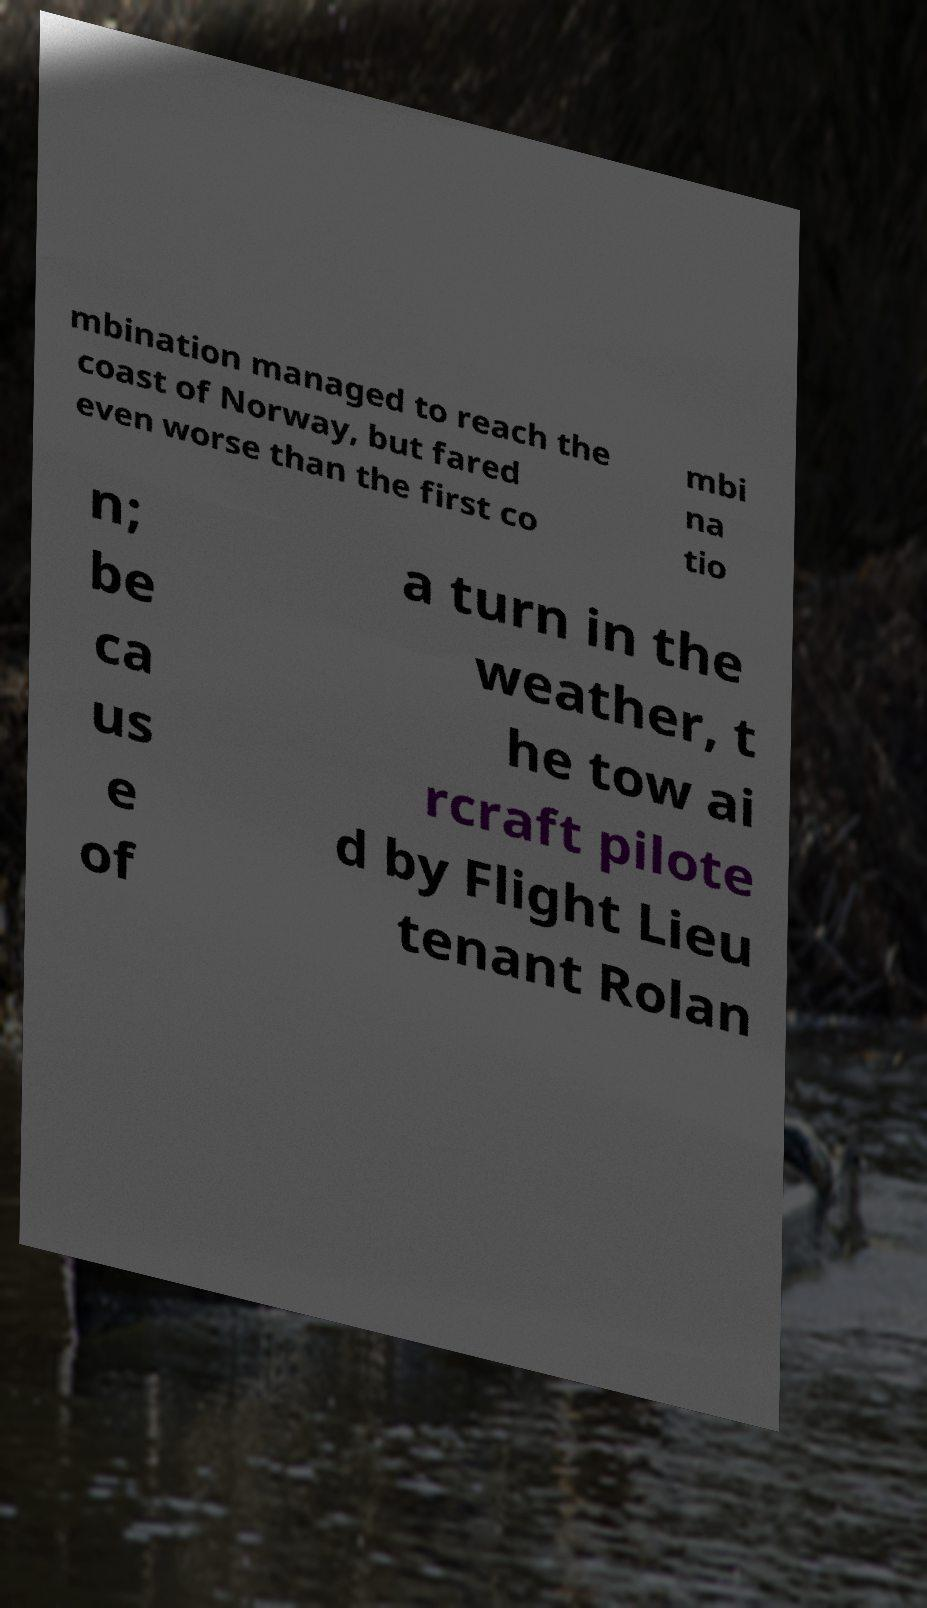Could you assist in decoding the text presented in this image and type it out clearly? mbination managed to reach the coast of Norway, but fared even worse than the first co mbi na tio n; be ca us e of a turn in the weather, t he tow ai rcraft pilote d by Flight Lieu tenant Rolan 